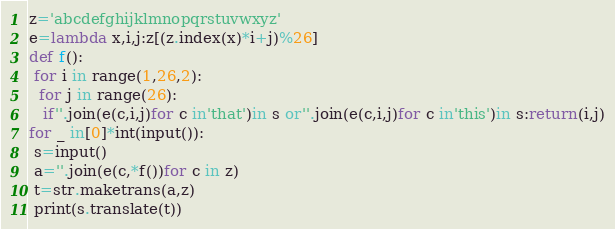<code> <loc_0><loc_0><loc_500><loc_500><_Python_>z='abcdefghijklmnopqrstuvwxyz'
e=lambda x,i,j:z[(z.index(x)*i+j)%26]
def f():
 for i in range(1,26,2):
  for j in range(26):
   if''.join(e(c,i,j)for c in'that')in s or''.join(e(c,i,j)for c in'this')in s:return(i,j)
for _ in[0]*int(input()):
 s=input()
 a=''.join(e(c,*f())for c in z)
 t=str.maketrans(a,z)
 print(s.translate(t))
</code> 